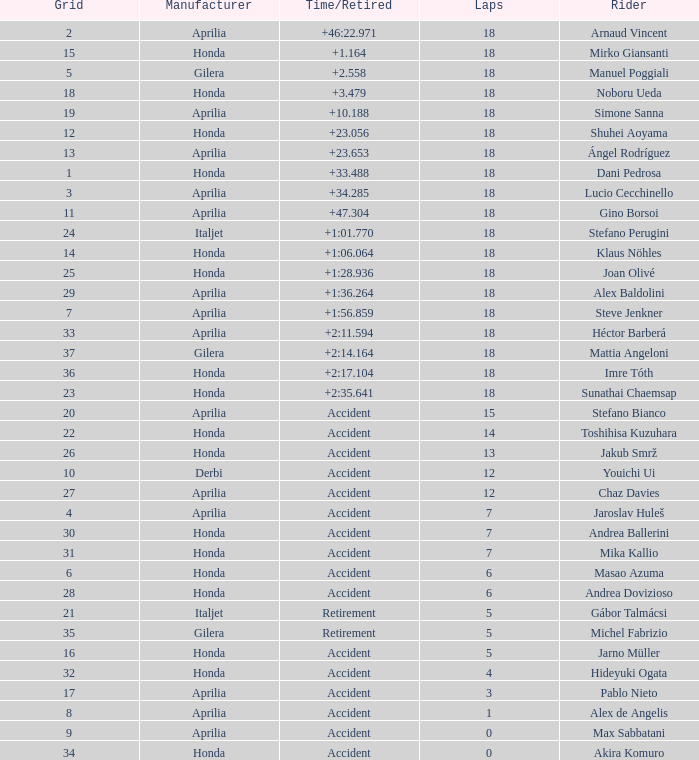Who is the rider with less than 15 laps, more than 32 grids, and an accident time/retired? Akira Komuro. 